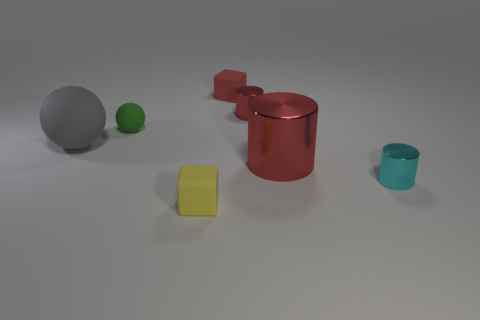Does the rubber thing that is to the left of the tiny green sphere have the same color as the small ball?
Provide a succinct answer. No. Are there the same number of big cylinders that are left of the red matte cube and tiny yellow things behind the tiny cyan shiny cylinder?
Provide a succinct answer. Yes. Is there anything else that is made of the same material as the large red object?
Give a very brief answer. Yes. The rubber object in front of the large matte ball is what color?
Provide a short and direct response. Yellow. Is the number of large spheres that are in front of the small yellow rubber cube the same as the number of tiny cyan shiny things?
Your answer should be compact. No. How many other objects are there of the same shape as the tiny yellow rubber thing?
Give a very brief answer. 1. There is a large ball; what number of big objects are right of it?
Your answer should be very brief. 1. What size is the metallic object that is to the left of the cyan metal cylinder and in front of the small red shiny thing?
Give a very brief answer. Large. Are there any small brown shiny objects?
Your answer should be compact. No. What number of other objects are the same size as the gray matte object?
Keep it short and to the point. 1. 